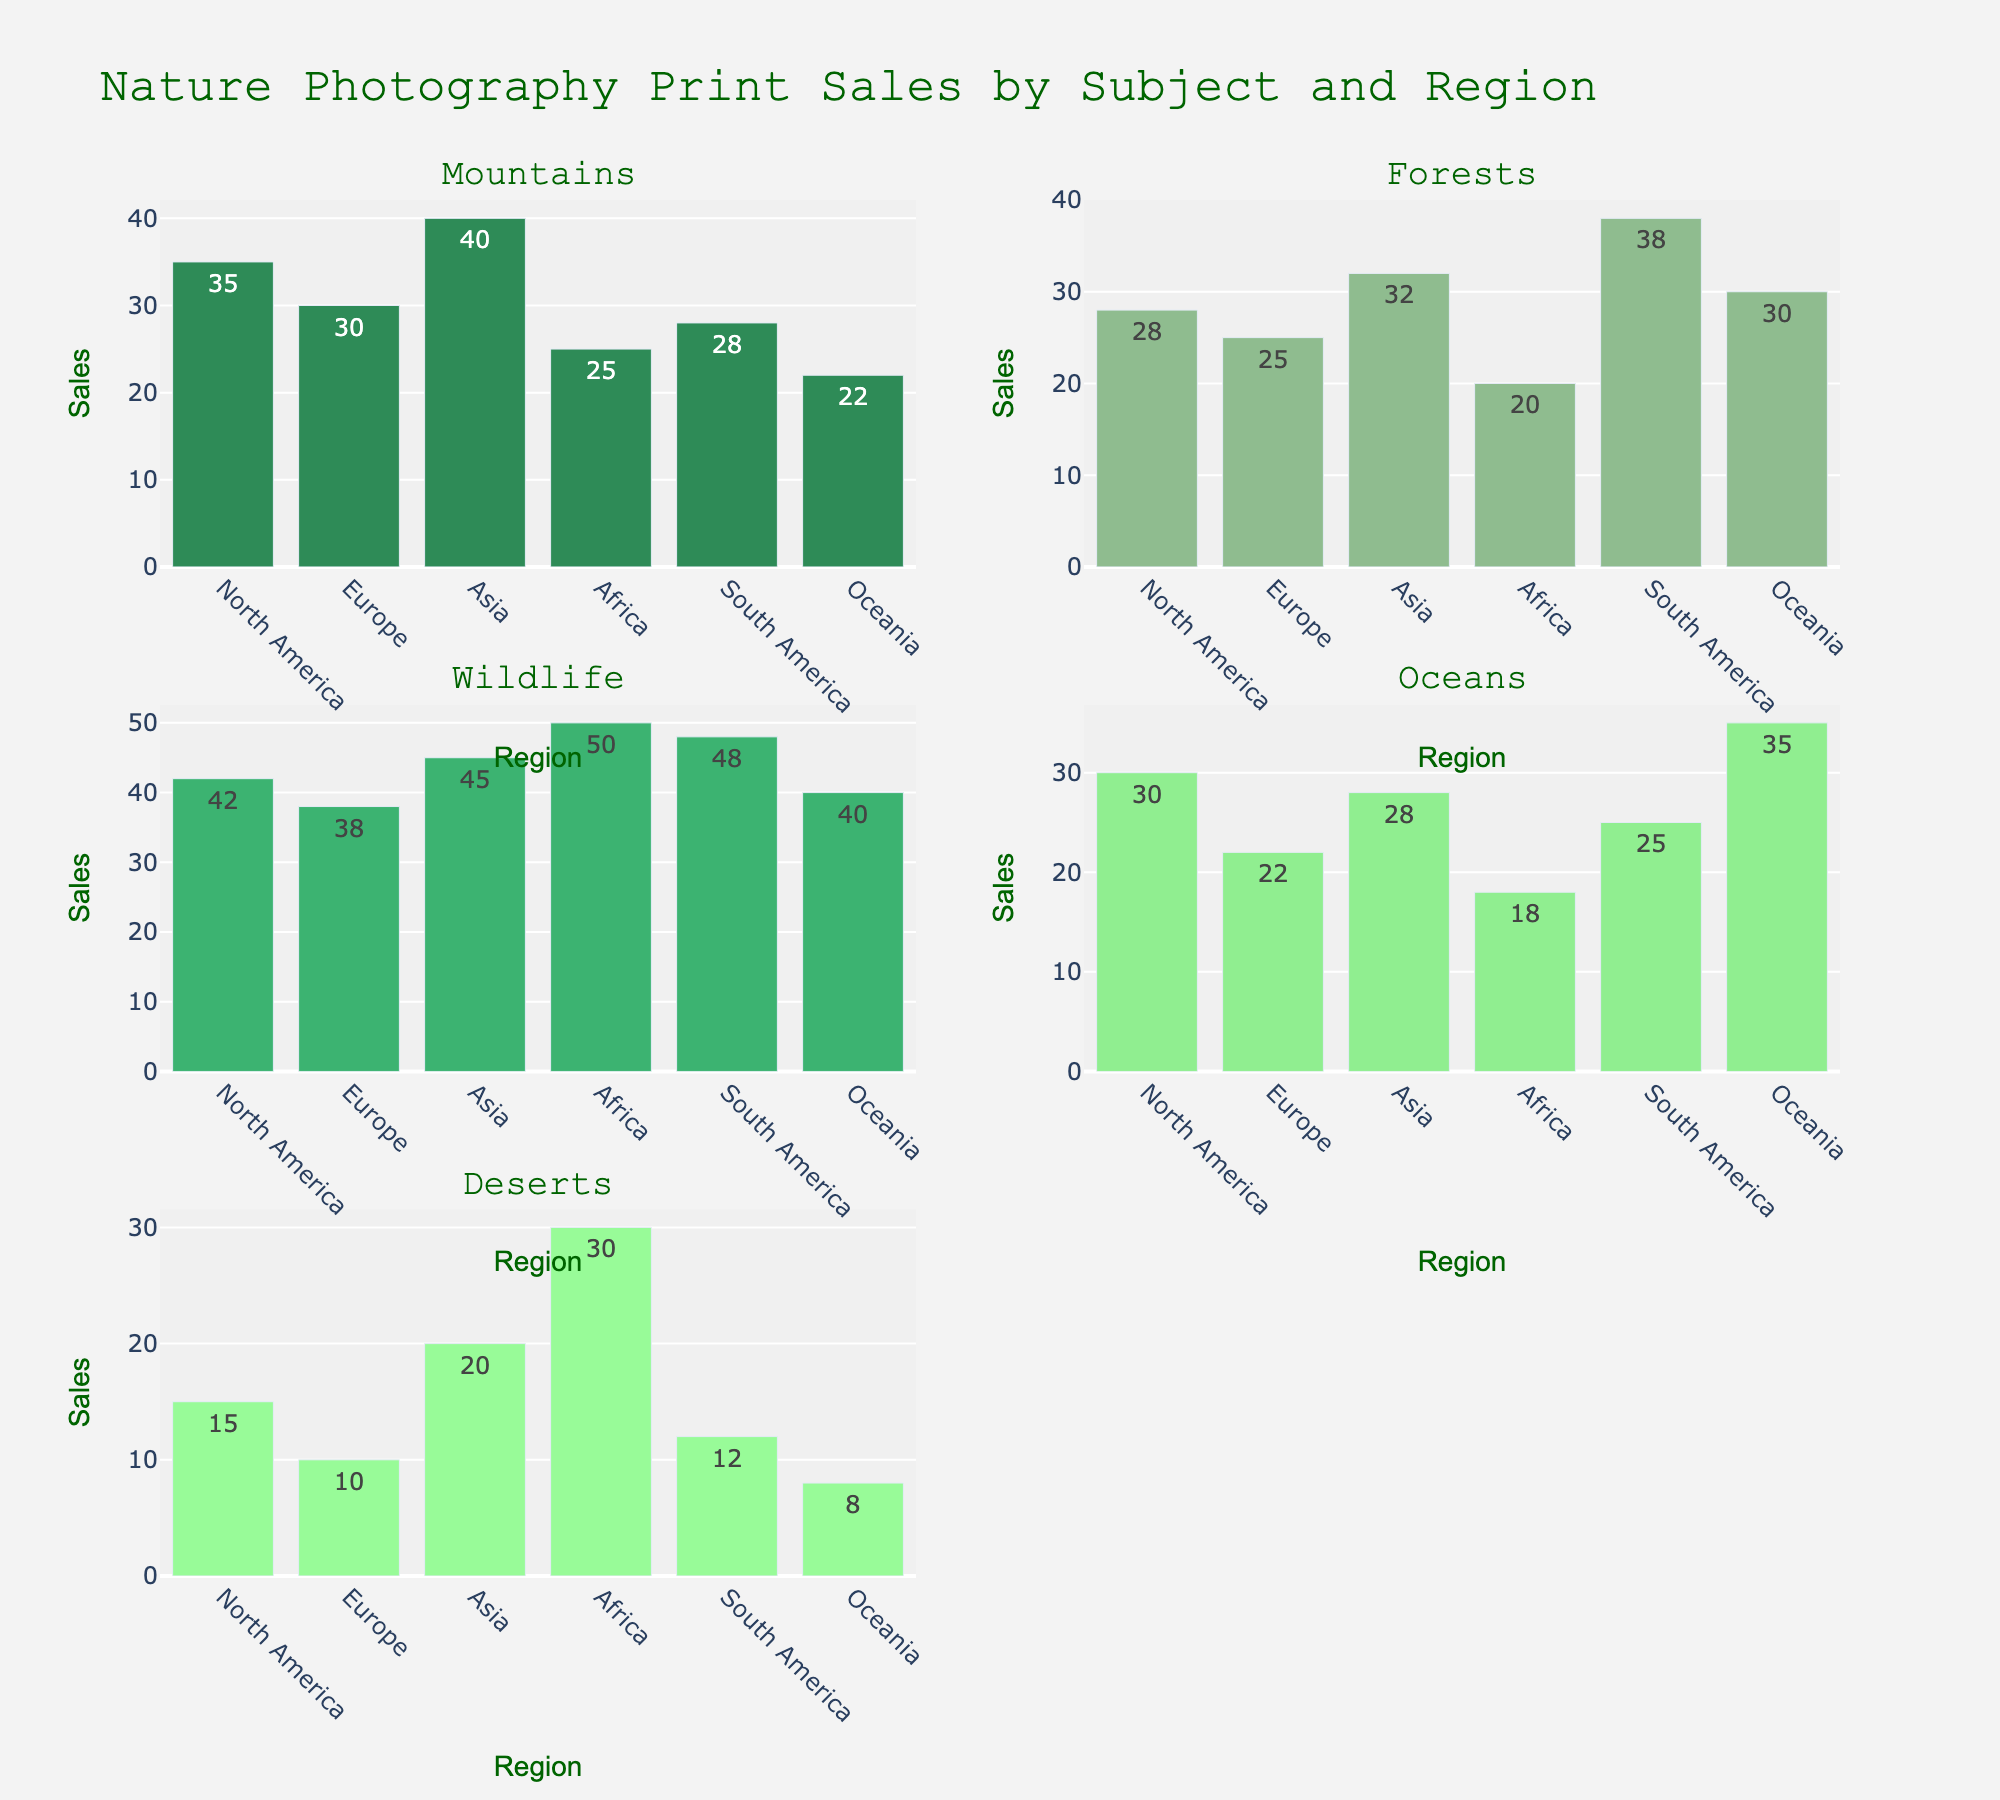What's the title of the figure? The title of the figure is usually placed prominently at the top and provides the main context of what the figure visualizes.
Answer: Nature Photography Print Sales by Subject and Region What color is used to represent Mountains in the bar chart? The color used to represent each subject matter is distinct and easily recognizable. For Mountains, it is the first color in the custom palette provided in the code.
Answer: Green (similar to Sea Green) Which region has the highest sales for Wildlife? By examining the subplot for Wildlife, identify which bar reaches the highest point on the y-axis, then match it to the corresponding region on the x-axis.
Answer: Africa What region has the lowest sales for Oceans? In the subplot for Oceans, check the heights of all bars and find the shortest one, corresponding to the region on the x-axis.
Answer: Africa How do the sales for Deserts in North America compare to those in Oceania? Look at the Deserts subplot, comparing the heights of the bars for North America and Oceania. Identify which bar is taller or if they are similar.
Answer: North America has higher sales Which subject has the lowest overall sales across all regions? Sum up the sales for each subject across all regions and compare these totals to identify the subject with the smallest sum.
Answer: Deserts What's the difference in sales for Forests between Europe and South America? In the Forests subplot, find the sales figures for Europe and South America, then subtract the smaller value from the larger to get the difference.
Answer: 13 What's the average sales for Mountains across all regions? Add the sales figures for Mountains across all regions, then divide by the number of regions to get the average.
Answer: 30 In which subject does Asia have the highest sales, and what is the value? For each subplot, find the sales figure for Asia, then determine which one is the highest.
Answer: Wildlife, 45 What is the total sales for all subjects in South America? For South America, add up the sales figures from all subject matter subplots to get the total.
Answer: 151 